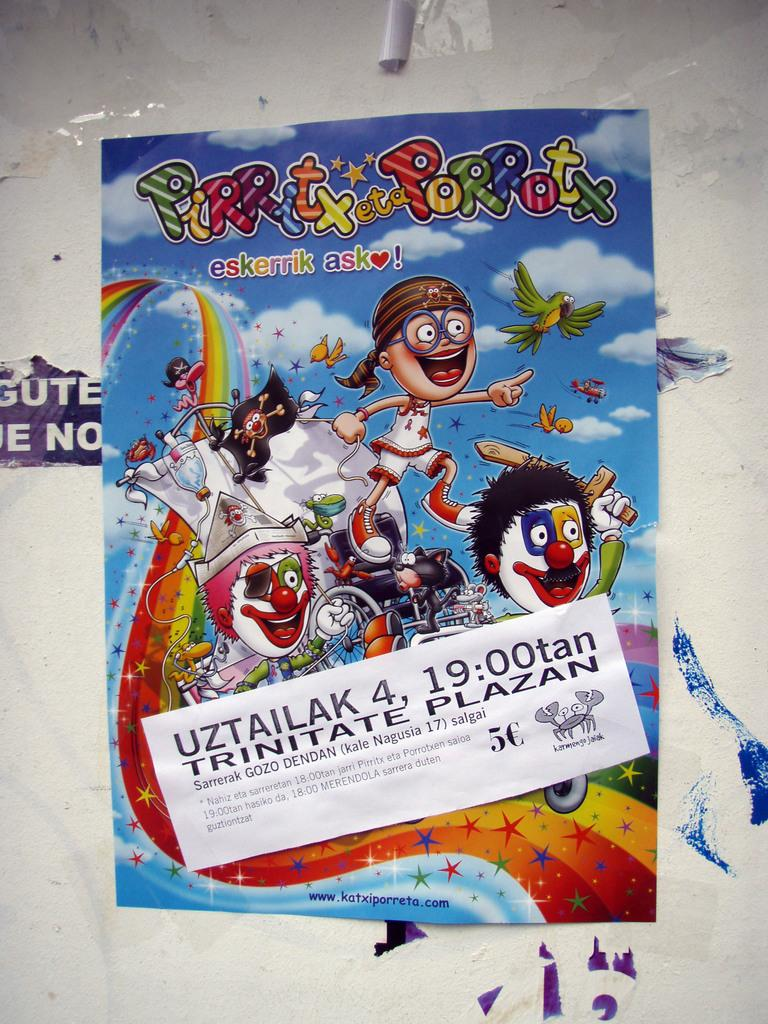<image>
Write a terse but informative summary of the picture. A poster with the title Pirritx eta Porrotx. 